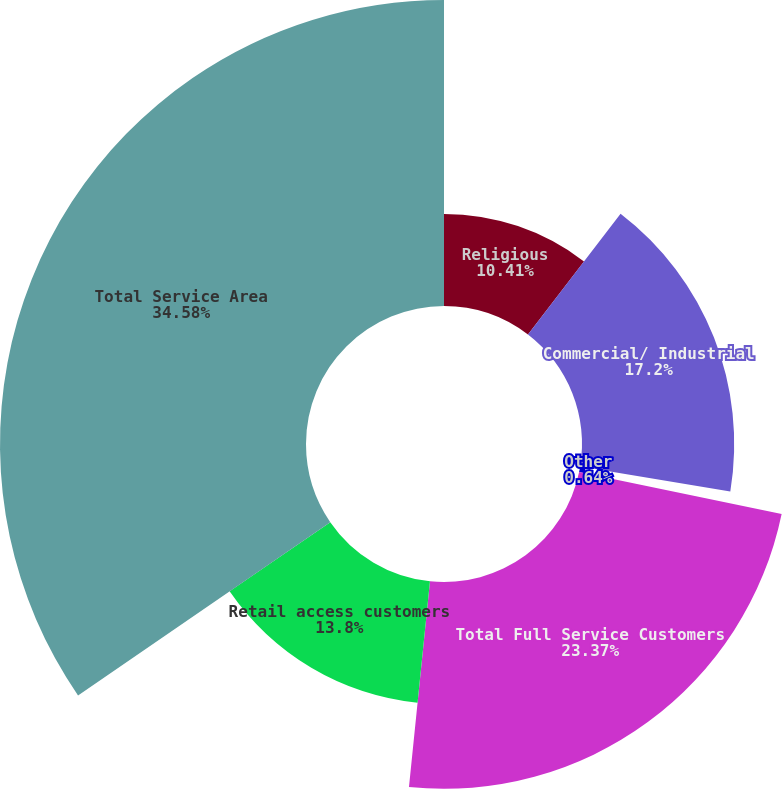Convert chart to OTSL. <chart><loc_0><loc_0><loc_500><loc_500><pie_chart><fcel>Religious<fcel>Commercial/ Industrial<fcel>Other<fcel>Total Full Service Customers<fcel>Retail access customers<fcel>Total Service Area<nl><fcel>10.41%<fcel>17.2%<fcel>0.64%<fcel>23.37%<fcel>13.8%<fcel>34.58%<nl></chart> 